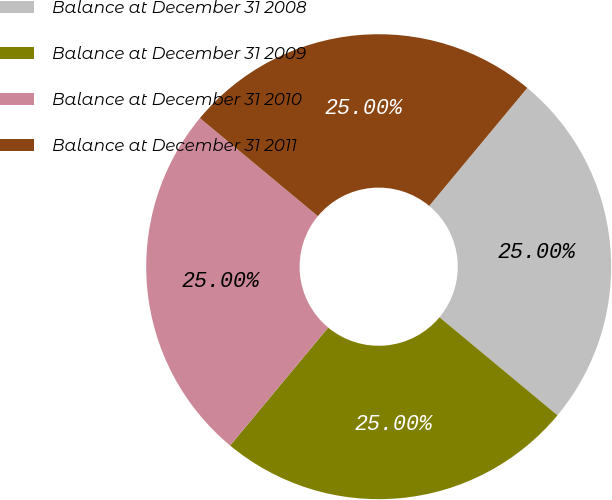Convert chart. <chart><loc_0><loc_0><loc_500><loc_500><pie_chart><fcel>Balance at December 31 2008<fcel>Balance at December 31 2009<fcel>Balance at December 31 2010<fcel>Balance at December 31 2011<nl><fcel>25.0%<fcel>25.0%<fcel>25.0%<fcel>25.0%<nl></chart> 